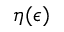Convert formula to latex. <formula><loc_0><loc_0><loc_500><loc_500>\eta ( \epsilon )</formula> 